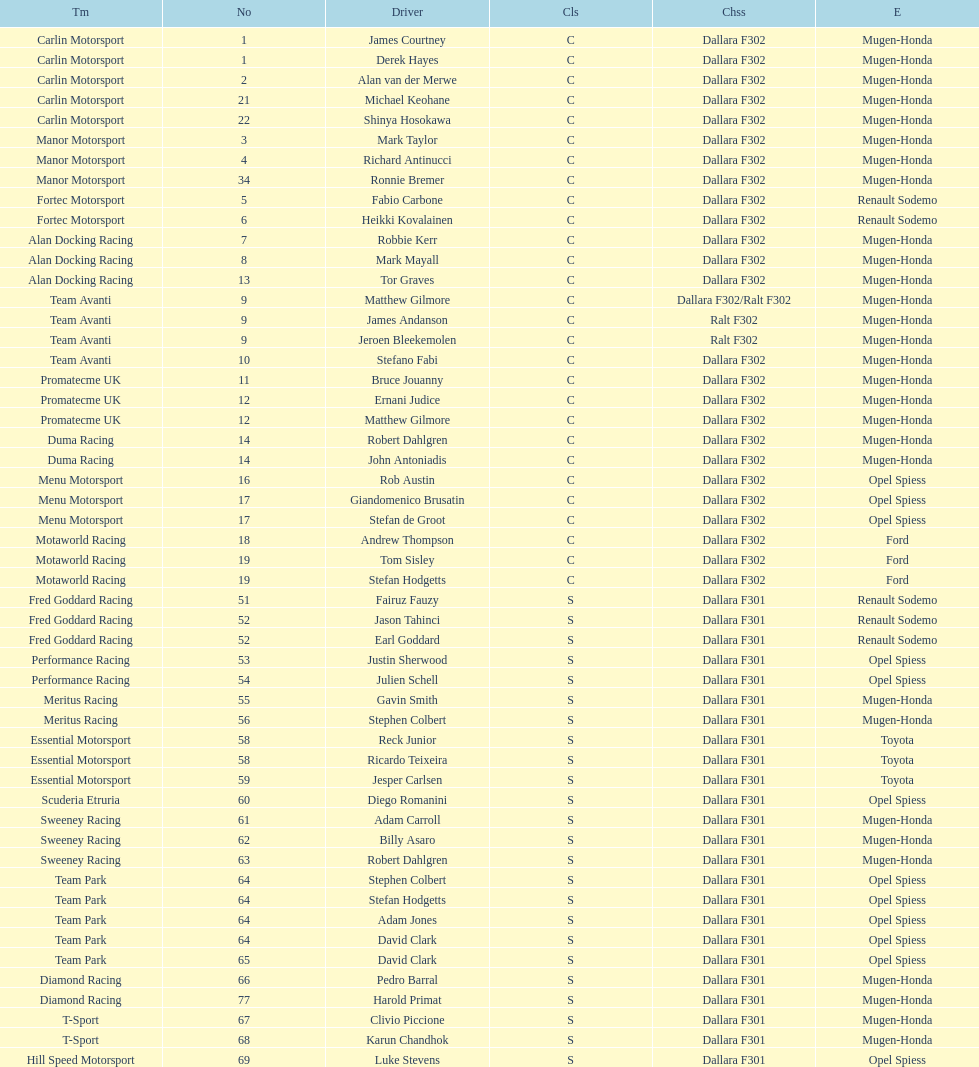Could you help me parse every detail presented in this table? {'header': ['Tm', 'No', 'Driver', 'Cls', 'Chss', 'E'], 'rows': [['Carlin Motorsport', '1', 'James Courtney', 'C', 'Dallara F302', 'Mugen-Honda'], ['Carlin Motorsport', '1', 'Derek Hayes', 'C', 'Dallara F302', 'Mugen-Honda'], ['Carlin Motorsport', '2', 'Alan van der Merwe', 'C', 'Dallara F302', 'Mugen-Honda'], ['Carlin Motorsport', '21', 'Michael Keohane', 'C', 'Dallara F302', 'Mugen-Honda'], ['Carlin Motorsport', '22', 'Shinya Hosokawa', 'C', 'Dallara F302', 'Mugen-Honda'], ['Manor Motorsport', '3', 'Mark Taylor', 'C', 'Dallara F302', 'Mugen-Honda'], ['Manor Motorsport', '4', 'Richard Antinucci', 'C', 'Dallara F302', 'Mugen-Honda'], ['Manor Motorsport', '34', 'Ronnie Bremer', 'C', 'Dallara F302', 'Mugen-Honda'], ['Fortec Motorsport', '5', 'Fabio Carbone', 'C', 'Dallara F302', 'Renault Sodemo'], ['Fortec Motorsport', '6', 'Heikki Kovalainen', 'C', 'Dallara F302', 'Renault Sodemo'], ['Alan Docking Racing', '7', 'Robbie Kerr', 'C', 'Dallara F302', 'Mugen-Honda'], ['Alan Docking Racing', '8', 'Mark Mayall', 'C', 'Dallara F302', 'Mugen-Honda'], ['Alan Docking Racing', '13', 'Tor Graves', 'C', 'Dallara F302', 'Mugen-Honda'], ['Team Avanti', '9', 'Matthew Gilmore', 'C', 'Dallara F302/Ralt F302', 'Mugen-Honda'], ['Team Avanti', '9', 'James Andanson', 'C', 'Ralt F302', 'Mugen-Honda'], ['Team Avanti', '9', 'Jeroen Bleekemolen', 'C', 'Ralt F302', 'Mugen-Honda'], ['Team Avanti', '10', 'Stefano Fabi', 'C', 'Dallara F302', 'Mugen-Honda'], ['Promatecme UK', '11', 'Bruce Jouanny', 'C', 'Dallara F302', 'Mugen-Honda'], ['Promatecme UK', '12', 'Ernani Judice', 'C', 'Dallara F302', 'Mugen-Honda'], ['Promatecme UK', '12', 'Matthew Gilmore', 'C', 'Dallara F302', 'Mugen-Honda'], ['Duma Racing', '14', 'Robert Dahlgren', 'C', 'Dallara F302', 'Mugen-Honda'], ['Duma Racing', '14', 'John Antoniadis', 'C', 'Dallara F302', 'Mugen-Honda'], ['Menu Motorsport', '16', 'Rob Austin', 'C', 'Dallara F302', 'Opel Spiess'], ['Menu Motorsport', '17', 'Giandomenico Brusatin', 'C', 'Dallara F302', 'Opel Spiess'], ['Menu Motorsport', '17', 'Stefan de Groot', 'C', 'Dallara F302', 'Opel Spiess'], ['Motaworld Racing', '18', 'Andrew Thompson', 'C', 'Dallara F302', 'Ford'], ['Motaworld Racing', '19', 'Tom Sisley', 'C', 'Dallara F302', 'Ford'], ['Motaworld Racing', '19', 'Stefan Hodgetts', 'C', 'Dallara F302', 'Ford'], ['Fred Goddard Racing', '51', 'Fairuz Fauzy', 'S', 'Dallara F301', 'Renault Sodemo'], ['Fred Goddard Racing', '52', 'Jason Tahinci', 'S', 'Dallara F301', 'Renault Sodemo'], ['Fred Goddard Racing', '52', 'Earl Goddard', 'S', 'Dallara F301', 'Renault Sodemo'], ['Performance Racing', '53', 'Justin Sherwood', 'S', 'Dallara F301', 'Opel Spiess'], ['Performance Racing', '54', 'Julien Schell', 'S', 'Dallara F301', 'Opel Spiess'], ['Meritus Racing', '55', 'Gavin Smith', 'S', 'Dallara F301', 'Mugen-Honda'], ['Meritus Racing', '56', 'Stephen Colbert', 'S', 'Dallara F301', 'Mugen-Honda'], ['Essential Motorsport', '58', 'Reck Junior', 'S', 'Dallara F301', 'Toyota'], ['Essential Motorsport', '58', 'Ricardo Teixeira', 'S', 'Dallara F301', 'Toyota'], ['Essential Motorsport', '59', 'Jesper Carlsen', 'S', 'Dallara F301', 'Toyota'], ['Scuderia Etruria', '60', 'Diego Romanini', 'S', 'Dallara F301', 'Opel Spiess'], ['Sweeney Racing', '61', 'Adam Carroll', 'S', 'Dallara F301', 'Mugen-Honda'], ['Sweeney Racing', '62', 'Billy Asaro', 'S', 'Dallara F301', 'Mugen-Honda'], ['Sweeney Racing', '63', 'Robert Dahlgren', 'S', 'Dallara F301', 'Mugen-Honda'], ['Team Park', '64', 'Stephen Colbert', 'S', 'Dallara F301', 'Opel Spiess'], ['Team Park', '64', 'Stefan Hodgetts', 'S', 'Dallara F301', 'Opel Spiess'], ['Team Park', '64', 'Adam Jones', 'S', 'Dallara F301', 'Opel Spiess'], ['Team Park', '64', 'David Clark', 'S', 'Dallara F301', 'Opel Spiess'], ['Team Park', '65', 'David Clark', 'S', 'Dallara F301', 'Opel Spiess'], ['Diamond Racing', '66', 'Pedro Barral', 'S', 'Dallara F301', 'Mugen-Honda'], ['Diamond Racing', '77', 'Harold Primat', 'S', 'Dallara F301', 'Mugen-Honda'], ['T-Sport', '67', 'Clivio Piccione', 'S', 'Dallara F301', 'Mugen-Honda'], ['T-Sport', '68', 'Karun Chandhok', 'S', 'Dallara F301', 'Mugen-Honda'], ['Hill Speed Motorsport', '69', 'Luke Stevens', 'S', 'Dallara F301', 'Opel Spiess']]} What is the average number of teams that had a mugen-honda engine? 24. 